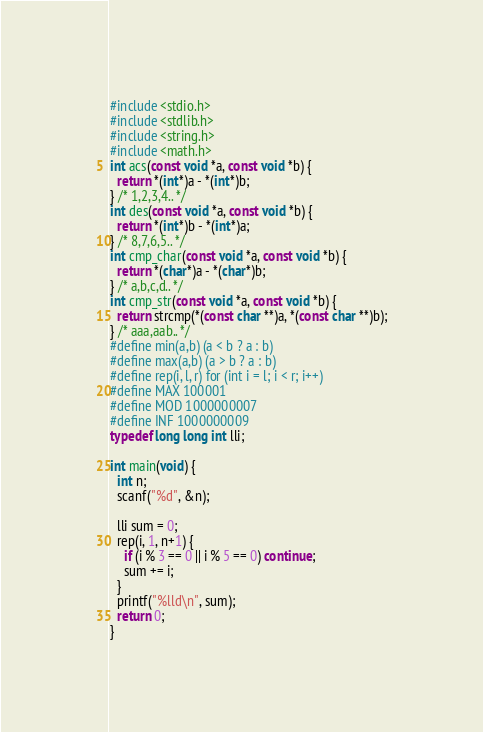<code> <loc_0><loc_0><loc_500><loc_500><_C_>#include <stdio.h>
#include <stdlib.h>
#include <string.h>
#include <math.h>
int acs(const void *a, const void *b) { 
  return *(int*)a - *(int*)b;
} /* 1,2,3,4.. */
int des(const void *a, const void *b) {
  return *(int*)b - *(int*)a;
} /* 8,7,6,5.. */
int cmp_char(const void *a, const void *b) { 
  return *(char*)a - *(char*)b;
} /* a,b,c,d.. */
int cmp_str(const void *a, const void *b) {
  return strcmp(*(const char **)a, *(const char **)b);
} /* aaa,aab.. */
#define min(a,b) (a < b ? a : b)
#define max(a,b) (a > b ? a : b)
#define rep(i, l, r) for (int i = l; i < r; i++)
#define MAX 100001
#define MOD 1000000007
#define INF 1000000009
typedef long long int lli;

int main(void) {
  int n;
  scanf("%d", &n);

  lli sum = 0;
  rep(i, 1, n+1) {
    if (i % 3 == 0 || i % 5 == 0) continue;
    sum += i;
  }  
  printf("%lld\n", sum);
  return 0;
}
</code> 